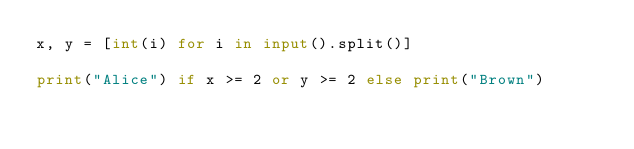Convert code to text. <code><loc_0><loc_0><loc_500><loc_500><_Python_>x, y = [int(i) for i in input().split()]

print("Alice") if x >= 2 or y >= 2 else print("Brown")</code> 